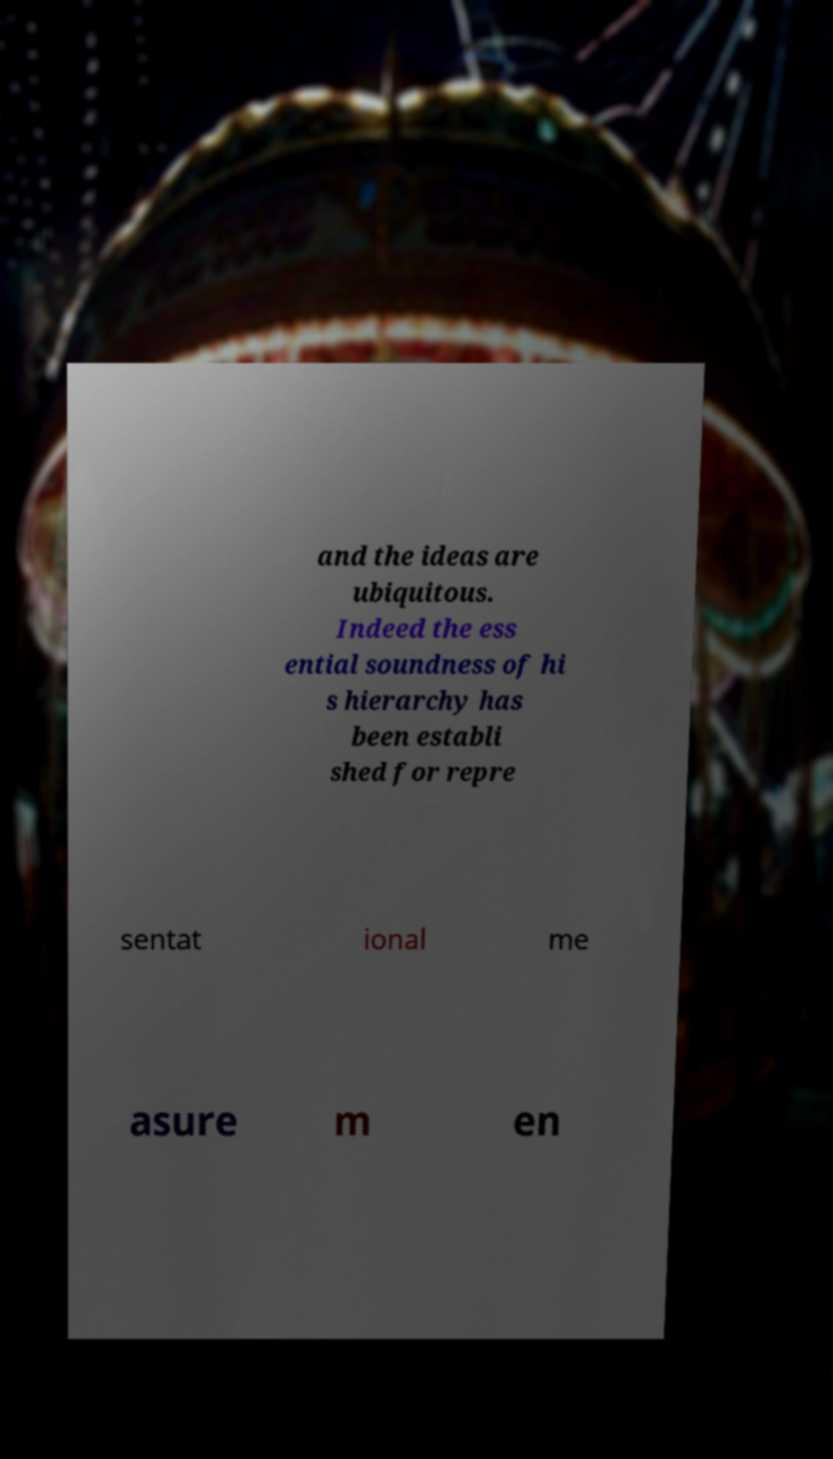Could you extract and type out the text from this image? and the ideas are ubiquitous. Indeed the ess ential soundness of hi s hierarchy has been establi shed for repre sentat ional me asure m en 